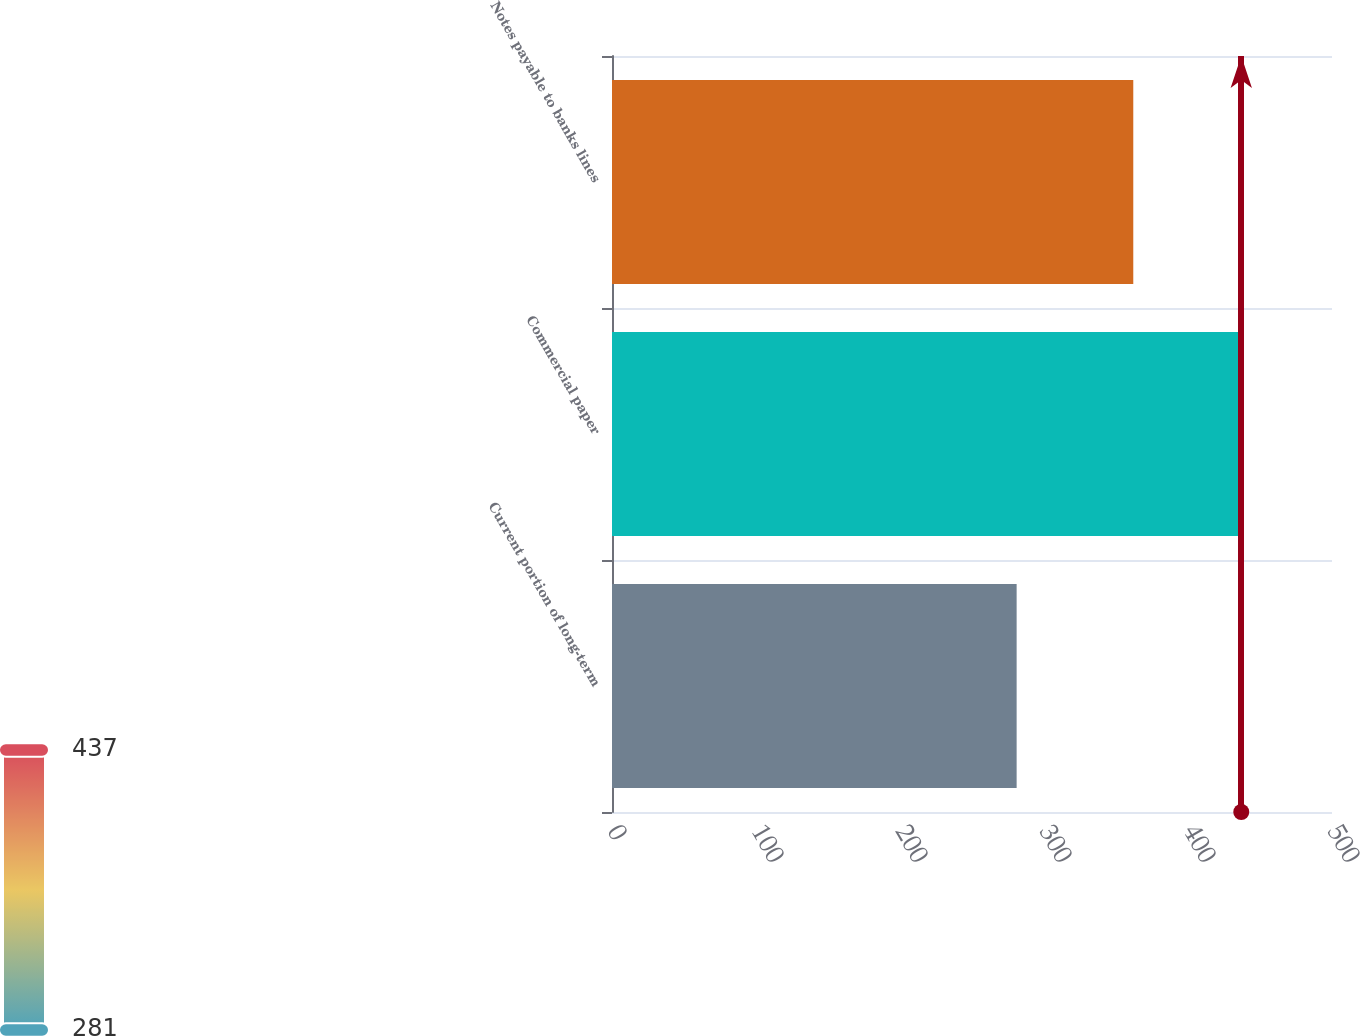<chart> <loc_0><loc_0><loc_500><loc_500><bar_chart><fcel>Current portion of long-term<fcel>Commercial paper<fcel>Notes payable to banks lines<nl><fcel>281<fcel>437<fcel>362<nl></chart> 